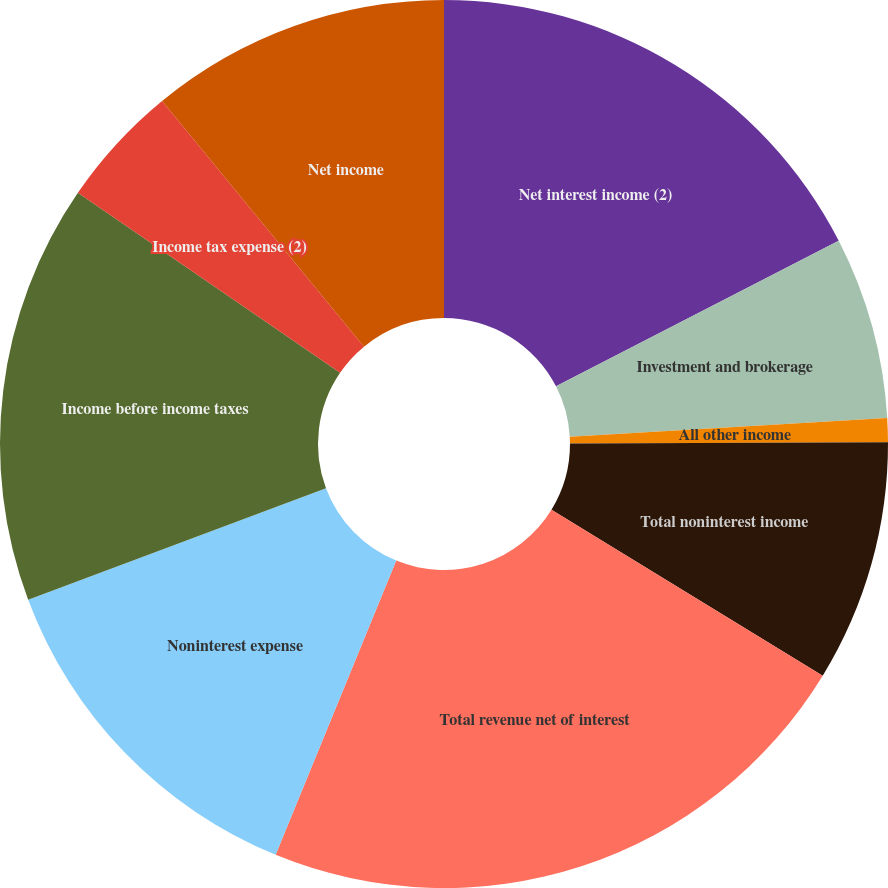Convert chart. <chart><loc_0><loc_0><loc_500><loc_500><pie_chart><fcel>Net interest income (2)<fcel>Investment and brokerage<fcel>All other income<fcel>Total noninterest income<fcel>Total revenue net of interest<fcel>Noninterest expense<fcel>Income before income taxes<fcel>Income tax expense (2)<fcel>Net income<nl><fcel>17.43%<fcel>6.64%<fcel>0.87%<fcel>8.8%<fcel>22.45%<fcel>13.11%<fcel>15.27%<fcel>4.48%<fcel>10.95%<nl></chart> 